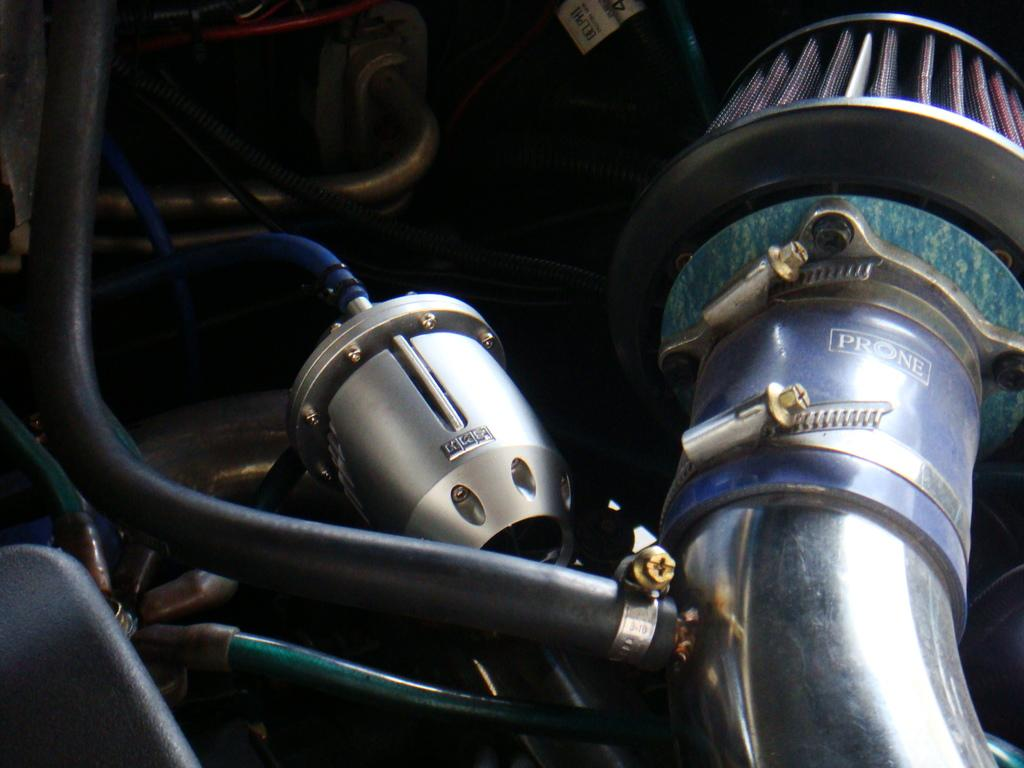What is the main subject of the image? The main subject of the image is an engine. What other objects can be seen in the image? There are rods and pipes in the image. Can you see a frog sitting on the engine in the image? No, there is no frog present in the image. What type of sand can be seen in the image? There is no sand present in the image. 